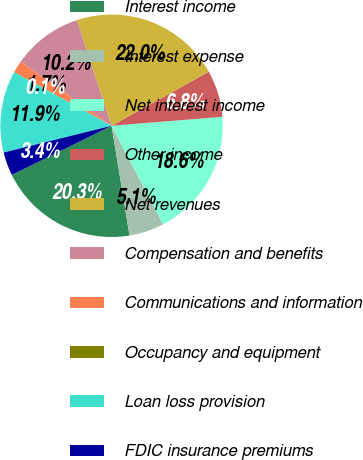Convert chart. <chart><loc_0><loc_0><loc_500><loc_500><pie_chart><fcel>Interest income<fcel>Interest expense<fcel>Net interest income<fcel>Other income<fcel>Net revenues<fcel>Compensation and benefits<fcel>Communications and information<fcel>Occupancy and equipment<fcel>Loan loss provision<fcel>FDIC insurance premiums<nl><fcel>20.29%<fcel>5.11%<fcel>18.6%<fcel>6.79%<fcel>21.98%<fcel>10.17%<fcel>1.73%<fcel>0.05%<fcel>11.86%<fcel>3.42%<nl></chart> 